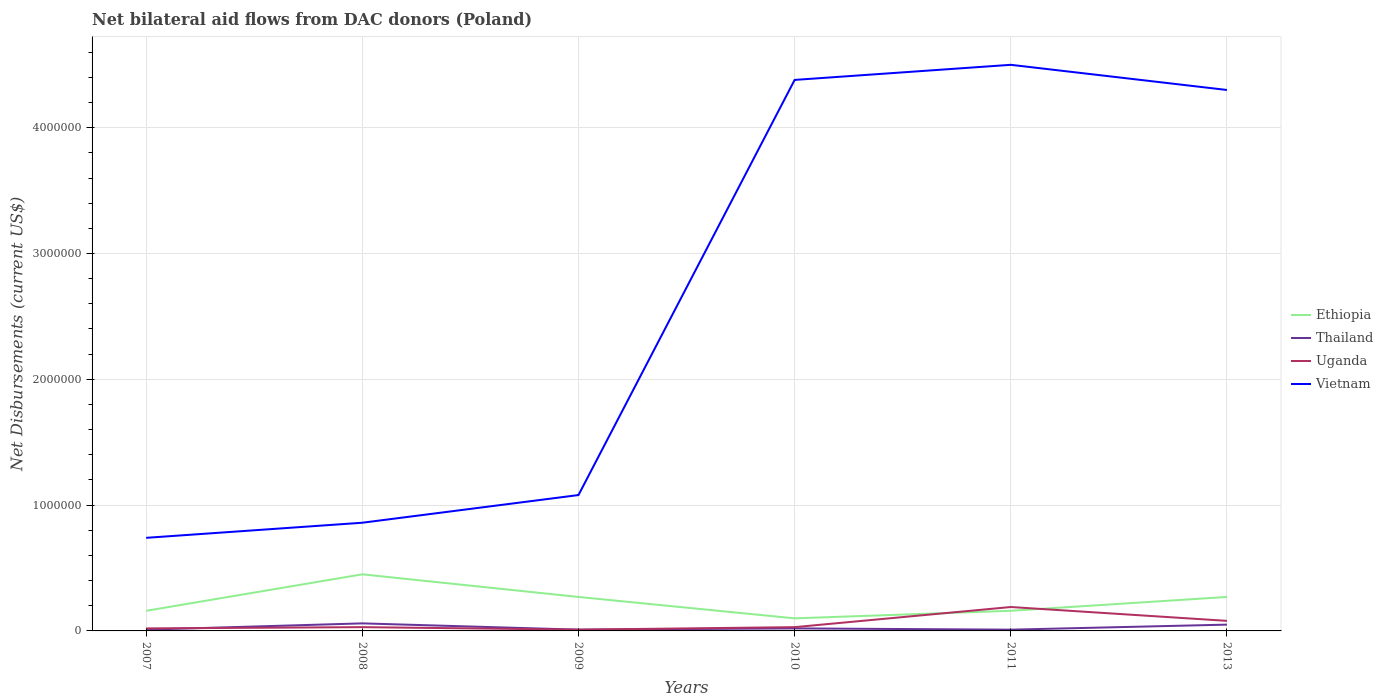How many different coloured lines are there?
Give a very brief answer. 4. Is the number of lines equal to the number of legend labels?
Your answer should be very brief. Yes. Across all years, what is the maximum net bilateral aid flows in Ethiopia?
Provide a succinct answer. 1.00e+05. In which year was the net bilateral aid flows in Uganda maximum?
Your answer should be compact. 2009. What is the total net bilateral aid flows in Uganda in the graph?
Provide a short and direct response. -6.00e+04. What is the difference between the highest and the second highest net bilateral aid flows in Ethiopia?
Keep it short and to the point. 3.50e+05. What is the difference between the highest and the lowest net bilateral aid flows in Vietnam?
Make the answer very short. 3. How many lines are there?
Make the answer very short. 4. What is the difference between two consecutive major ticks on the Y-axis?
Make the answer very short. 1.00e+06. What is the title of the graph?
Your response must be concise. Net bilateral aid flows from DAC donors (Poland). Does "Guam" appear as one of the legend labels in the graph?
Make the answer very short. No. What is the label or title of the Y-axis?
Offer a very short reply. Net Disbursements (current US$). What is the Net Disbursements (current US$) in Ethiopia in 2007?
Give a very brief answer. 1.60e+05. What is the Net Disbursements (current US$) in Vietnam in 2007?
Ensure brevity in your answer.  7.40e+05. What is the Net Disbursements (current US$) of Ethiopia in 2008?
Make the answer very short. 4.50e+05. What is the Net Disbursements (current US$) in Thailand in 2008?
Offer a terse response. 6.00e+04. What is the Net Disbursements (current US$) in Uganda in 2008?
Your answer should be very brief. 3.00e+04. What is the Net Disbursements (current US$) of Vietnam in 2008?
Your response must be concise. 8.60e+05. What is the Net Disbursements (current US$) in Ethiopia in 2009?
Ensure brevity in your answer.  2.70e+05. What is the Net Disbursements (current US$) in Vietnam in 2009?
Provide a short and direct response. 1.08e+06. What is the Net Disbursements (current US$) in Thailand in 2010?
Offer a terse response. 2.00e+04. What is the Net Disbursements (current US$) in Vietnam in 2010?
Provide a succinct answer. 4.38e+06. What is the Net Disbursements (current US$) in Uganda in 2011?
Make the answer very short. 1.90e+05. What is the Net Disbursements (current US$) in Vietnam in 2011?
Your response must be concise. 4.50e+06. What is the Net Disbursements (current US$) of Ethiopia in 2013?
Provide a succinct answer. 2.70e+05. What is the Net Disbursements (current US$) of Vietnam in 2013?
Make the answer very short. 4.30e+06. Across all years, what is the maximum Net Disbursements (current US$) in Ethiopia?
Provide a short and direct response. 4.50e+05. Across all years, what is the maximum Net Disbursements (current US$) of Vietnam?
Your response must be concise. 4.50e+06. Across all years, what is the minimum Net Disbursements (current US$) in Thailand?
Offer a very short reply. 10000. Across all years, what is the minimum Net Disbursements (current US$) in Uganda?
Ensure brevity in your answer.  10000. Across all years, what is the minimum Net Disbursements (current US$) in Vietnam?
Offer a very short reply. 7.40e+05. What is the total Net Disbursements (current US$) in Ethiopia in the graph?
Make the answer very short. 1.41e+06. What is the total Net Disbursements (current US$) of Thailand in the graph?
Give a very brief answer. 1.60e+05. What is the total Net Disbursements (current US$) of Vietnam in the graph?
Your answer should be very brief. 1.59e+07. What is the difference between the Net Disbursements (current US$) of Ethiopia in 2007 and that in 2008?
Give a very brief answer. -2.90e+05. What is the difference between the Net Disbursements (current US$) of Thailand in 2007 and that in 2008?
Keep it short and to the point. -5.00e+04. What is the difference between the Net Disbursements (current US$) of Uganda in 2007 and that in 2008?
Your answer should be very brief. -10000. What is the difference between the Net Disbursements (current US$) in Vietnam in 2007 and that in 2008?
Give a very brief answer. -1.20e+05. What is the difference between the Net Disbursements (current US$) of Thailand in 2007 and that in 2009?
Offer a very short reply. 0. What is the difference between the Net Disbursements (current US$) of Uganda in 2007 and that in 2009?
Give a very brief answer. 10000. What is the difference between the Net Disbursements (current US$) in Vietnam in 2007 and that in 2010?
Offer a terse response. -3.64e+06. What is the difference between the Net Disbursements (current US$) of Ethiopia in 2007 and that in 2011?
Offer a very short reply. 0. What is the difference between the Net Disbursements (current US$) of Thailand in 2007 and that in 2011?
Provide a short and direct response. 0. What is the difference between the Net Disbursements (current US$) of Uganda in 2007 and that in 2011?
Give a very brief answer. -1.70e+05. What is the difference between the Net Disbursements (current US$) of Vietnam in 2007 and that in 2011?
Keep it short and to the point. -3.76e+06. What is the difference between the Net Disbursements (current US$) in Uganda in 2007 and that in 2013?
Your response must be concise. -6.00e+04. What is the difference between the Net Disbursements (current US$) of Vietnam in 2007 and that in 2013?
Your answer should be very brief. -3.56e+06. What is the difference between the Net Disbursements (current US$) in Thailand in 2008 and that in 2009?
Keep it short and to the point. 5.00e+04. What is the difference between the Net Disbursements (current US$) of Vietnam in 2008 and that in 2009?
Your answer should be very brief. -2.20e+05. What is the difference between the Net Disbursements (current US$) in Ethiopia in 2008 and that in 2010?
Your answer should be very brief. 3.50e+05. What is the difference between the Net Disbursements (current US$) in Vietnam in 2008 and that in 2010?
Your answer should be compact. -3.52e+06. What is the difference between the Net Disbursements (current US$) of Ethiopia in 2008 and that in 2011?
Keep it short and to the point. 2.90e+05. What is the difference between the Net Disbursements (current US$) of Thailand in 2008 and that in 2011?
Your response must be concise. 5.00e+04. What is the difference between the Net Disbursements (current US$) of Vietnam in 2008 and that in 2011?
Provide a short and direct response. -3.64e+06. What is the difference between the Net Disbursements (current US$) in Ethiopia in 2008 and that in 2013?
Make the answer very short. 1.80e+05. What is the difference between the Net Disbursements (current US$) in Thailand in 2008 and that in 2013?
Ensure brevity in your answer.  10000. What is the difference between the Net Disbursements (current US$) in Vietnam in 2008 and that in 2013?
Provide a succinct answer. -3.44e+06. What is the difference between the Net Disbursements (current US$) of Uganda in 2009 and that in 2010?
Your response must be concise. -2.00e+04. What is the difference between the Net Disbursements (current US$) of Vietnam in 2009 and that in 2010?
Your response must be concise. -3.30e+06. What is the difference between the Net Disbursements (current US$) in Ethiopia in 2009 and that in 2011?
Your response must be concise. 1.10e+05. What is the difference between the Net Disbursements (current US$) of Thailand in 2009 and that in 2011?
Make the answer very short. 0. What is the difference between the Net Disbursements (current US$) in Vietnam in 2009 and that in 2011?
Provide a short and direct response. -3.42e+06. What is the difference between the Net Disbursements (current US$) of Ethiopia in 2009 and that in 2013?
Your answer should be compact. 0. What is the difference between the Net Disbursements (current US$) in Vietnam in 2009 and that in 2013?
Offer a very short reply. -3.22e+06. What is the difference between the Net Disbursements (current US$) of Uganda in 2010 and that in 2011?
Your answer should be compact. -1.60e+05. What is the difference between the Net Disbursements (current US$) in Ethiopia in 2010 and that in 2013?
Provide a short and direct response. -1.70e+05. What is the difference between the Net Disbursements (current US$) in Ethiopia in 2011 and that in 2013?
Ensure brevity in your answer.  -1.10e+05. What is the difference between the Net Disbursements (current US$) of Thailand in 2011 and that in 2013?
Your answer should be compact. -4.00e+04. What is the difference between the Net Disbursements (current US$) in Uganda in 2011 and that in 2013?
Give a very brief answer. 1.10e+05. What is the difference between the Net Disbursements (current US$) of Ethiopia in 2007 and the Net Disbursements (current US$) of Vietnam in 2008?
Provide a short and direct response. -7.00e+05. What is the difference between the Net Disbursements (current US$) of Thailand in 2007 and the Net Disbursements (current US$) of Uganda in 2008?
Make the answer very short. -2.00e+04. What is the difference between the Net Disbursements (current US$) in Thailand in 2007 and the Net Disbursements (current US$) in Vietnam in 2008?
Keep it short and to the point. -8.50e+05. What is the difference between the Net Disbursements (current US$) in Uganda in 2007 and the Net Disbursements (current US$) in Vietnam in 2008?
Keep it short and to the point. -8.40e+05. What is the difference between the Net Disbursements (current US$) of Ethiopia in 2007 and the Net Disbursements (current US$) of Uganda in 2009?
Give a very brief answer. 1.50e+05. What is the difference between the Net Disbursements (current US$) of Ethiopia in 2007 and the Net Disbursements (current US$) of Vietnam in 2009?
Your response must be concise. -9.20e+05. What is the difference between the Net Disbursements (current US$) of Thailand in 2007 and the Net Disbursements (current US$) of Uganda in 2009?
Your answer should be very brief. 0. What is the difference between the Net Disbursements (current US$) of Thailand in 2007 and the Net Disbursements (current US$) of Vietnam in 2009?
Your answer should be compact. -1.07e+06. What is the difference between the Net Disbursements (current US$) of Uganda in 2007 and the Net Disbursements (current US$) of Vietnam in 2009?
Provide a short and direct response. -1.06e+06. What is the difference between the Net Disbursements (current US$) in Ethiopia in 2007 and the Net Disbursements (current US$) in Vietnam in 2010?
Ensure brevity in your answer.  -4.22e+06. What is the difference between the Net Disbursements (current US$) in Thailand in 2007 and the Net Disbursements (current US$) in Uganda in 2010?
Your answer should be very brief. -2.00e+04. What is the difference between the Net Disbursements (current US$) in Thailand in 2007 and the Net Disbursements (current US$) in Vietnam in 2010?
Provide a short and direct response. -4.37e+06. What is the difference between the Net Disbursements (current US$) in Uganda in 2007 and the Net Disbursements (current US$) in Vietnam in 2010?
Provide a short and direct response. -4.36e+06. What is the difference between the Net Disbursements (current US$) of Ethiopia in 2007 and the Net Disbursements (current US$) of Uganda in 2011?
Make the answer very short. -3.00e+04. What is the difference between the Net Disbursements (current US$) in Ethiopia in 2007 and the Net Disbursements (current US$) in Vietnam in 2011?
Your response must be concise. -4.34e+06. What is the difference between the Net Disbursements (current US$) of Thailand in 2007 and the Net Disbursements (current US$) of Uganda in 2011?
Your response must be concise. -1.80e+05. What is the difference between the Net Disbursements (current US$) of Thailand in 2007 and the Net Disbursements (current US$) of Vietnam in 2011?
Ensure brevity in your answer.  -4.49e+06. What is the difference between the Net Disbursements (current US$) of Uganda in 2007 and the Net Disbursements (current US$) of Vietnam in 2011?
Your response must be concise. -4.48e+06. What is the difference between the Net Disbursements (current US$) in Ethiopia in 2007 and the Net Disbursements (current US$) in Uganda in 2013?
Ensure brevity in your answer.  8.00e+04. What is the difference between the Net Disbursements (current US$) in Ethiopia in 2007 and the Net Disbursements (current US$) in Vietnam in 2013?
Offer a terse response. -4.14e+06. What is the difference between the Net Disbursements (current US$) of Thailand in 2007 and the Net Disbursements (current US$) of Uganda in 2013?
Give a very brief answer. -7.00e+04. What is the difference between the Net Disbursements (current US$) in Thailand in 2007 and the Net Disbursements (current US$) in Vietnam in 2013?
Your answer should be very brief. -4.29e+06. What is the difference between the Net Disbursements (current US$) in Uganda in 2007 and the Net Disbursements (current US$) in Vietnam in 2013?
Keep it short and to the point. -4.28e+06. What is the difference between the Net Disbursements (current US$) in Ethiopia in 2008 and the Net Disbursements (current US$) in Thailand in 2009?
Provide a succinct answer. 4.40e+05. What is the difference between the Net Disbursements (current US$) in Ethiopia in 2008 and the Net Disbursements (current US$) in Uganda in 2009?
Your response must be concise. 4.40e+05. What is the difference between the Net Disbursements (current US$) of Ethiopia in 2008 and the Net Disbursements (current US$) of Vietnam in 2009?
Keep it short and to the point. -6.30e+05. What is the difference between the Net Disbursements (current US$) of Thailand in 2008 and the Net Disbursements (current US$) of Vietnam in 2009?
Provide a short and direct response. -1.02e+06. What is the difference between the Net Disbursements (current US$) in Uganda in 2008 and the Net Disbursements (current US$) in Vietnam in 2009?
Keep it short and to the point. -1.05e+06. What is the difference between the Net Disbursements (current US$) of Ethiopia in 2008 and the Net Disbursements (current US$) of Uganda in 2010?
Your answer should be very brief. 4.20e+05. What is the difference between the Net Disbursements (current US$) in Ethiopia in 2008 and the Net Disbursements (current US$) in Vietnam in 2010?
Your answer should be very brief. -3.93e+06. What is the difference between the Net Disbursements (current US$) of Thailand in 2008 and the Net Disbursements (current US$) of Vietnam in 2010?
Offer a very short reply. -4.32e+06. What is the difference between the Net Disbursements (current US$) of Uganda in 2008 and the Net Disbursements (current US$) of Vietnam in 2010?
Keep it short and to the point. -4.35e+06. What is the difference between the Net Disbursements (current US$) of Ethiopia in 2008 and the Net Disbursements (current US$) of Vietnam in 2011?
Provide a succinct answer. -4.05e+06. What is the difference between the Net Disbursements (current US$) of Thailand in 2008 and the Net Disbursements (current US$) of Vietnam in 2011?
Your answer should be compact. -4.44e+06. What is the difference between the Net Disbursements (current US$) in Uganda in 2008 and the Net Disbursements (current US$) in Vietnam in 2011?
Give a very brief answer. -4.47e+06. What is the difference between the Net Disbursements (current US$) of Ethiopia in 2008 and the Net Disbursements (current US$) of Vietnam in 2013?
Offer a very short reply. -3.85e+06. What is the difference between the Net Disbursements (current US$) of Thailand in 2008 and the Net Disbursements (current US$) of Uganda in 2013?
Provide a short and direct response. -2.00e+04. What is the difference between the Net Disbursements (current US$) of Thailand in 2008 and the Net Disbursements (current US$) of Vietnam in 2013?
Provide a short and direct response. -4.24e+06. What is the difference between the Net Disbursements (current US$) of Uganda in 2008 and the Net Disbursements (current US$) of Vietnam in 2013?
Offer a terse response. -4.27e+06. What is the difference between the Net Disbursements (current US$) of Ethiopia in 2009 and the Net Disbursements (current US$) of Uganda in 2010?
Offer a very short reply. 2.40e+05. What is the difference between the Net Disbursements (current US$) in Ethiopia in 2009 and the Net Disbursements (current US$) in Vietnam in 2010?
Offer a very short reply. -4.11e+06. What is the difference between the Net Disbursements (current US$) in Thailand in 2009 and the Net Disbursements (current US$) in Vietnam in 2010?
Your response must be concise. -4.37e+06. What is the difference between the Net Disbursements (current US$) of Uganda in 2009 and the Net Disbursements (current US$) of Vietnam in 2010?
Your answer should be very brief. -4.37e+06. What is the difference between the Net Disbursements (current US$) in Ethiopia in 2009 and the Net Disbursements (current US$) in Uganda in 2011?
Ensure brevity in your answer.  8.00e+04. What is the difference between the Net Disbursements (current US$) in Ethiopia in 2009 and the Net Disbursements (current US$) in Vietnam in 2011?
Keep it short and to the point. -4.23e+06. What is the difference between the Net Disbursements (current US$) of Thailand in 2009 and the Net Disbursements (current US$) of Vietnam in 2011?
Provide a short and direct response. -4.49e+06. What is the difference between the Net Disbursements (current US$) of Uganda in 2009 and the Net Disbursements (current US$) of Vietnam in 2011?
Provide a short and direct response. -4.49e+06. What is the difference between the Net Disbursements (current US$) in Ethiopia in 2009 and the Net Disbursements (current US$) in Thailand in 2013?
Make the answer very short. 2.20e+05. What is the difference between the Net Disbursements (current US$) of Ethiopia in 2009 and the Net Disbursements (current US$) of Uganda in 2013?
Your answer should be compact. 1.90e+05. What is the difference between the Net Disbursements (current US$) of Ethiopia in 2009 and the Net Disbursements (current US$) of Vietnam in 2013?
Ensure brevity in your answer.  -4.03e+06. What is the difference between the Net Disbursements (current US$) in Thailand in 2009 and the Net Disbursements (current US$) in Uganda in 2013?
Make the answer very short. -7.00e+04. What is the difference between the Net Disbursements (current US$) of Thailand in 2009 and the Net Disbursements (current US$) of Vietnam in 2013?
Give a very brief answer. -4.29e+06. What is the difference between the Net Disbursements (current US$) in Uganda in 2009 and the Net Disbursements (current US$) in Vietnam in 2013?
Make the answer very short. -4.29e+06. What is the difference between the Net Disbursements (current US$) of Ethiopia in 2010 and the Net Disbursements (current US$) of Thailand in 2011?
Your answer should be very brief. 9.00e+04. What is the difference between the Net Disbursements (current US$) in Ethiopia in 2010 and the Net Disbursements (current US$) in Vietnam in 2011?
Your answer should be compact. -4.40e+06. What is the difference between the Net Disbursements (current US$) in Thailand in 2010 and the Net Disbursements (current US$) in Uganda in 2011?
Offer a terse response. -1.70e+05. What is the difference between the Net Disbursements (current US$) in Thailand in 2010 and the Net Disbursements (current US$) in Vietnam in 2011?
Your answer should be compact. -4.48e+06. What is the difference between the Net Disbursements (current US$) of Uganda in 2010 and the Net Disbursements (current US$) of Vietnam in 2011?
Ensure brevity in your answer.  -4.47e+06. What is the difference between the Net Disbursements (current US$) of Ethiopia in 2010 and the Net Disbursements (current US$) of Vietnam in 2013?
Give a very brief answer. -4.20e+06. What is the difference between the Net Disbursements (current US$) of Thailand in 2010 and the Net Disbursements (current US$) of Vietnam in 2013?
Keep it short and to the point. -4.28e+06. What is the difference between the Net Disbursements (current US$) of Uganda in 2010 and the Net Disbursements (current US$) of Vietnam in 2013?
Provide a short and direct response. -4.27e+06. What is the difference between the Net Disbursements (current US$) in Ethiopia in 2011 and the Net Disbursements (current US$) in Thailand in 2013?
Give a very brief answer. 1.10e+05. What is the difference between the Net Disbursements (current US$) in Ethiopia in 2011 and the Net Disbursements (current US$) in Uganda in 2013?
Your answer should be very brief. 8.00e+04. What is the difference between the Net Disbursements (current US$) of Ethiopia in 2011 and the Net Disbursements (current US$) of Vietnam in 2013?
Provide a succinct answer. -4.14e+06. What is the difference between the Net Disbursements (current US$) of Thailand in 2011 and the Net Disbursements (current US$) of Uganda in 2013?
Give a very brief answer. -7.00e+04. What is the difference between the Net Disbursements (current US$) of Thailand in 2011 and the Net Disbursements (current US$) of Vietnam in 2013?
Give a very brief answer. -4.29e+06. What is the difference between the Net Disbursements (current US$) of Uganda in 2011 and the Net Disbursements (current US$) of Vietnam in 2013?
Provide a short and direct response. -4.11e+06. What is the average Net Disbursements (current US$) in Ethiopia per year?
Give a very brief answer. 2.35e+05. What is the average Net Disbursements (current US$) of Thailand per year?
Ensure brevity in your answer.  2.67e+04. What is the average Net Disbursements (current US$) of Vietnam per year?
Give a very brief answer. 2.64e+06. In the year 2007, what is the difference between the Net Disbursements (current US$) of Ethiopia and Net Disbursements (current US$) of Thailand?
Your answer should be compact. 1.50e+05. In the year 2007, what is the difference between the Net Disbursements (current US$) of Ethiopia and Net Disbursements (current US$) of Vietnam?
Give a very brief answer. -5.80e+05. In the year 2007, what is the difference between the Net Disbursements (current US$) in Thailand and Net Disbursements (current US$) in Uganda?
Your response must be concise. -10000. In the year 2007, what is the difference between the Net Disbursements (current US$) in Thailand and Net Disbursements (current US$) in Vietnam?
Keep it short and to the point. -7.30e+05. In the year 2007, what is the difference between the Net Disbursements (current US$) of Uganda and Net Disbursements (current US$) of Vietnam?
Keep it short and to the point. -7.20e+05. In the year 2008, what is the difference between the Net Disbursements (current US$) of Ethiopia and Net Disbursements (current US$) of Thailand?
Ensure brevity in your answer.  3.90e+05. In the year 2008, what is the difference between the Net Disbursements (current US$) of Ethiopia and Net Disbursements (current US$) of Uganda?
Offer a very short reply. 4.20e+05. In the year 2008, what is the difference between the Net Disbursements (current US$) of Ethiopia and Net Disbursements (current US$) of Vietnam?
Provide a succinct answer. -4.10e+05. In the year 2008, what is the difference between the Net Disbursements (current US$) of Thailand and Net Disbursements (current US$) of Uganda?
Keep it short and to the point. 3.00e+04. In the year 2008, what is the difference between the Net Disbursements (current US$) in Thailand and Net Disbursements (current US$) in Vietnam?
Your answer should be compact. -8.00e+05. In the year 2008, what is the difference between the Net Disbursements (current US$) of Uganda and Net Disbursements (current US$) of Vietnam?
Ensure brevity in your answer.  -8.30e+05. In the year 2009, what is the difference between the Net Disbursements (current US$) of Ethiopia and Net Disbursements (current US$) of Uganda?
Your answer should be compact. 2.60e+05. In the year 2009, what is the difference between the Net Disbursements (current US$) of Ethiopia and Net Disbursements (current US$) of Vietnam?
Offer a very short reply. -8.10e+05. In the year 2009, what is the difference between the Net Disbursements (current US$) in Thailand and Net Disbursements (current US$) in Vietnam?
Offer a terse response. -1.07e+06. In the year 2009, what is the difference between the Net Disbursements (current US$) in Uganda and Net Disbursements (current US$) in Vietnam?
Offer a very short reply. -1.07e+06. In the year 2010, what is the difference between the Net Disbursements (current US$) in Ethiopia and Net Disbursements (current US$) in Thailand?
Provide a short and direct response. 8.00e+04. In the year 2010, what is the difference between the Net Disbursements (current US$) in Ethiopia and Net Disbursements (current US$) in Uganda?
Your answer should be compact. 7.00e+04. In the year 2010, what is the difference between the Net Disbursements (current US$) of Ethiopia and Net Disbursements (current US$) of Vietnam?
Offer a very short reply. -4.28e+06. In the year 2010, what is the difference between the Net Disbursements (current US$) in Thailand and Net Disbursements (current US$) in Vietnam?
Provide a succinct answer. -4.36e+06. In the year 2010, what is the difference between the Net Disbursements (current US$) in Uganda and Net Disbursements (current US$) in Vietnam?
Give a very brief answer. -4.35e+06. In the year 2011, what is the difference between the Net Disbursements (current US$) in Ethiopia and Net Disbursements (current US$) in Thailand?
Keep it short and to the point. 1.50e+05. In the year 2011, what is the difference between the Net Disbursements (current US$) in Ethiopia and Net Disbursements (current US$) in Uganda?
Offer a terse response. -3.00e+04. In the year 2011, what is the difference between the Net Disbursements (current US$) of Ethiopia and Net Disbursements (current US$) of Vietnam?
Your answer should be very brief. -4.34e+06. In the year 2011, what is the difference between the Net Disbursements (current US$) in Thailand and Net Disbursements (current US$) in Vietnam?
Provide a succinct answer. -4.49e+06. In the year 2011, what is the difference between the Net Disbursements (current US$) of Uganda and Net Disbursements (current US$) of Vietnam?
Offer a very short reply. -4.31e+06. In the year 2013, what is the difference between the Net Disbursements (current US$) of Ethiopia and Net Disbursements (current US$) of Thailand?
Provide a succinct answer. 2.20e+05. In the year 2013, what is the difference between the Net Disbursements (current US$) in Ethiopia and Net Disbursements (current US$) in Uganda?
Your answer should be very brief. 1.90e+05. In the year 2013, what is the difference between the Net Disbursements (current US$) in Ethiopia and Net Disbursements (current US$) in Vietnam?
Make the answer very short. -4.03e+06. In the year 2013, what is the difference between the Net Disbursements (current US$) of Thailand and Net Disbursements (current US$) of Uganda?
Your answer should be very brief. -3.00e+04. In the year 2013, what is the difference between the Net Disbursements (current US$) in Thailand and Net Disbursements (current US$) in Vietnam?
Offer a terse response. -4.25e+06. In the year 2013, what is the difference between the Net Disbursements (current US$) of Uganda and Net Disbursements (current US$) of Vietnam?
Your response must be concise. -4.22e+06. What is the ratio of the Net Disbursements (current US$) of Ethiopia in 2007 to that in 2008?
Your response must be concise. 0.36. What is the ratio of the Net Disbursements (current US$) in Thailand in 2007 to that in 2008?
Your response must be concise. 0.17. What is the ratio of the Net Disbursements (current US$) of Uganda in 2007 to that in 2008?
Your answer should be compact. 0.67. What is the ratio of the Net Disbursements (current US$) of Vietnam in 2007 to that in 2008?
Your response must be concise. 0.86. What is the ratio of the Net Disbursements (current US$) in Ethiopia in 2007 to that in 2009?
Make the answer very short. 0.59. What is the ratio of the Net Disbursements (current US$) in Thailand in 2007 to that in 2009?
Your response must be concise. 1. What is the ratio of the Net Disbursements (current US$) of Vietnam in 2007 to that in 2009?
Give a very brief answer. 0.69. What is the ratio of the Net Disbursements (current US$) in Uganda in 2007 to that in 2010?
Your answer should be compact. 0.67. What is the ratio of the Net Disbursements (current US$) in Vietnam in 2007 to that in 2010?
Your answer should be very brief. 0.17. What is the ratio of the Net Disbursements (current US$) of Ethiopia in 2007 to that in 2011?
Your answer should be compact. 1. What is the ratio of the Net Disbursements (current US$) of Thailand in 2007 to that in 2011?
Keep it short and to the point. 1. What is the ratio of the Net Disbursements (current US$) in Uganda in 2007 to that in 2011?
Your answer should be very brief. 0.11. What is the ratio of the Net Disbursements (current US$) in Vietnam in 2007 to that in 2011?
Your answer should be compact. 0.16. What is the ratio of the Net Disbursements (current US$) of Ethiopia in 2007 to that in 2013?
Make the answer very short. 0.59. What is the ratio of the Net Disbursements (current US$) in Vietnam in 2007 to that in 2013?
Provide a short and direct response. 0.17. What is the ratio of the Net Disbursements (current US$) of Vietnam in 2008 to that in 2009?
Ensure brevity in your answer.  0.8. What is the ratio of the Net Disbursements (current US$) of Thailand in 2008 to that in 2010?
Provide a succinct answer. 3. What is the ratio of the Net Disbursements (current US$) of Uganda in 2008 to that in 2010?
Make the answer very short. 1. What is the ratio of the Net Disbursements (current US$) in Vietnam in 2008 to that in 2010?
Provide a short and direct response. 0.2. What is the ratio of the Net Disbursements (current US$) in Ethiopia in 2008 to that in 2011?
Offer a very short reply. 2.81. What is the ratio of the Net Disbursements (current US$) in Thailand in 2008 to that in 2011?
Give a very brief answer. 6. What is the ratio of the Net Disbursements (current US$) in Uganda in 2008 to that in 2011?
Make the answer very short. 0.16. What is the ratio of the Net Disbursements (current US$) of Vietnam in 2008 to that in 2011?
Provide a short and direct response. 0.19. What is the ratio of the Net Disbursements (current US$) in Vietnam in 2008 to that in 2013?
Your answer should be compact. 0.2. What is the ratio of the Net Disbursements (current US$) of Ethiopia in 2009 to that in 2010?
Offer a terse response. 2.7. What is the ratio of the Net Disbursements (current US$) in Vietnam in 2009 to that in 2010?
Give a very brief answer. 0.25. What is the ratio of the Net Disbursements (current US$) of Ethiopia in 2009 to that in 2011?
Keep it short and to the point. 1.69. What is the ratio of the Net Disbursements (current US$) in Thailand in 2009 to that in 2011?
Your answer should be very brief. 1. What is the ratio of the Net Disbursements (current US$) of Uganda in 2009 to that in 2011?
Offer a very short reply. 0.05. What is the ratio of the Net Disbursements (current US$) of Vietnam in 2009 to that in 2011?
Ensure brevity in your answer.  0.24. What is the ratio of the Net Disbursements (current US$) of Vietnam in 2009 to that in 2013?
Give a very brief answer. 0.25. What is the ratio of the Net Disbursements (current US$) in Ethiopia in 2010 to that in 2011?
Your response must be concise. 0.62. What is the ratio of the Net Disbursements (current US$) of Thailand in 2010 to that in 2011?
Provide a succinct answer. 2. What is the ratio of the Net Disbursements (current US$) in Uganda in 2010 to that in 2011?
Your answer should be compact. 0.16. What is the ratio of the Net Disbursements (current US$) in Vietnam in 2010 to that in 2011?
Offer a terse response. 0.97. What is the ratio of the Net Disbursements (current US$) of Ethiopia in 2010 to that in 2013?
Your answer should be very brief. 0.37. What is the ratio of the Net Disbursements (current US$) of Thailand in 2010 to that in 2013?
Provide a short and direct response. 0.4. What is the ratio of the Net Disbursements (current US$) of Vietnam in 2010 to that in 2013?
Your response must be concise. 1.02. What is the ratio of the Net Disbursements (current US$) of Ethiopia in 2011 to that in 2013?
Keep it short and to the point. 0.59. What is the ratio of the Net Disbursements (current US$) in Uganda in 2011 to that in 2013?
Make the answer very short. 2.38. What is the ratio of the Net Disbursements (current US$) of Vietnam in 2011 to that in 2013?
Offer a very short reply. 1.05. What is the difference between the highest and the second highest Net Disbursements (current US$) in Ethiopia?
Offer a very short reply. 1.80e+05. What is the difference between the highest and the second highest Net Disbursements (current US$) in Thailand?
Your answer should be compact. 10000. What is the difference between the highest and the lowest Net Disbursements (current US$) of Thailand?
Offer a terse response. 5.00e+04. What is the difference between the highest and the lowest Net Disbursements (current US$) in Vietnam?
Your answer should be very brief. 3.76e+06. 